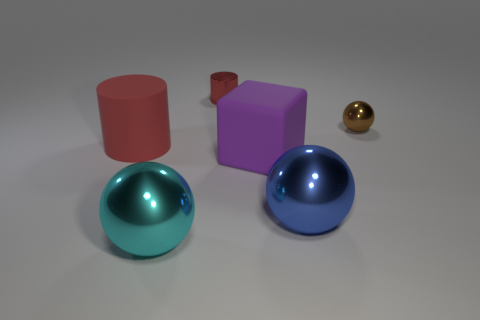Add 2 matte cylinders. How many objects exist? 8 Subtract all cubes. How many objects are left? 5 Subtract 0 gray blocks. How many objects are left? 6 Subtract all small cylinders. Subtract all blue spheres. How many objects are left? 4 Add 4 purple rubber cubes. How many purple rubber cubes are left? 5 Add 4 big cylinders. How many big cylinders exist? 5 